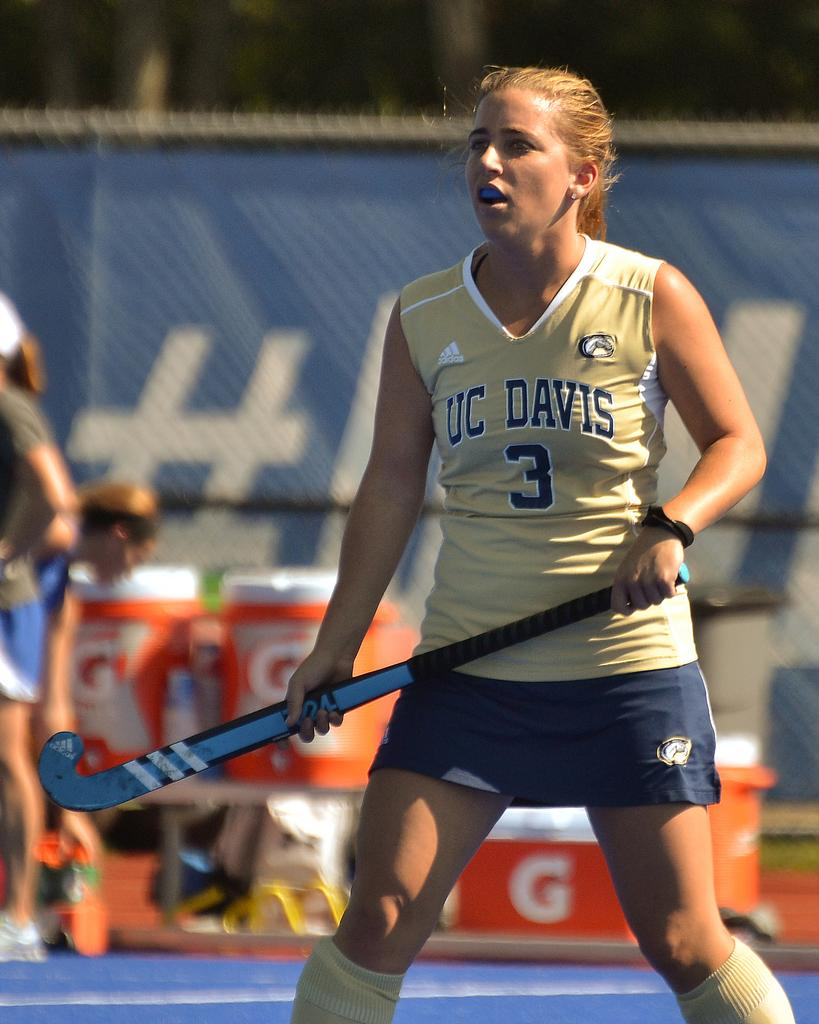<image>
Create a compact narrative representing the image presented. A UC Davis field hockey player wearing number 3 during a game 